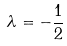Convert formula to latex. <formula><loc_0><loc_0><loc_500><loc_500>\lambda = - \frac { 1 } { 2 }</formula> 